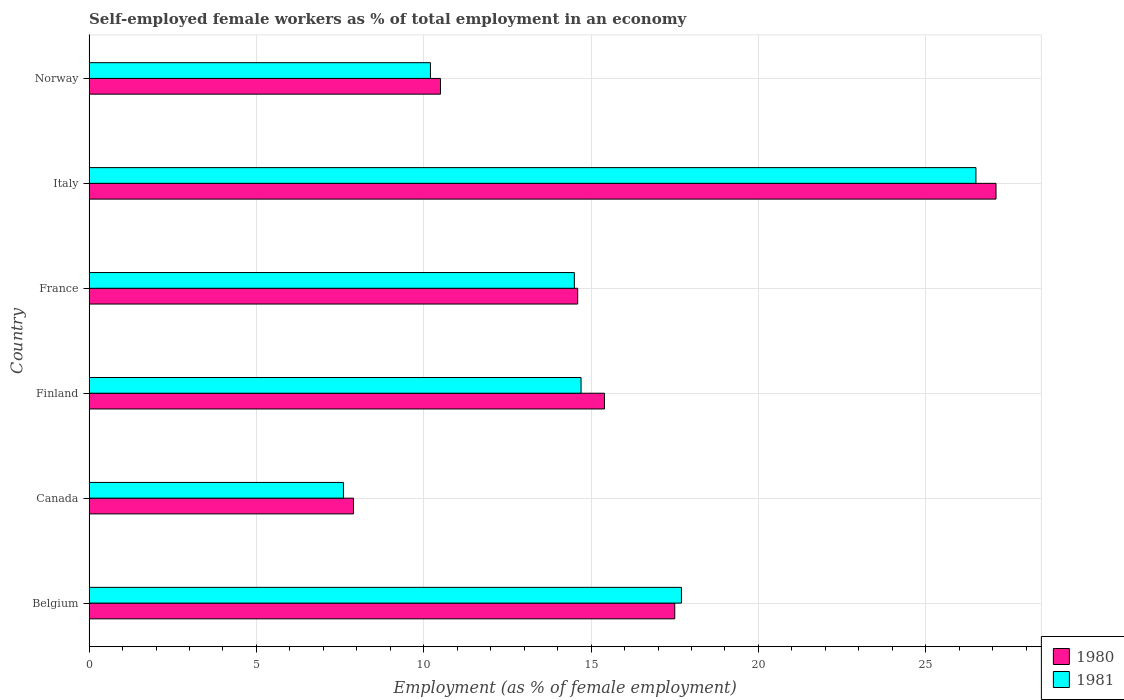How many different coloured bars are there?
Make the answer very short. 2. How many groups of bars are there?
Ensure brevity in your answer.  6. Are the number of bars per tick equal to the number of legend labels?
Your answer should be very brief. Yes. Are the number of bars on each tick of the Y-axis equal?
Provide a short and direct response. Yes. How many bars are there on the 2nd tick from the bottom?
Offer a very short reply. 2. In how many cases, is the number of bars for a given country not equal to the number of legend labels?
Provide a short and direct response. 0. What is the percentage of self-employed female workers in 1980 in France?
Offer a very short reply. 14.6. Across all countries, what is the maximum percentage of self-employed female workers in 1981?
Give a very brief answer. 26.5. Across all countries, what is the minimum percentage of self-employed female workers in 1980?
Keep it short and to the point. 7.9. What is the total percentage of self-employed female workers in 1981 in the graph?
Your response must be concise. 91.2. What is the difference between the percentage of self-employed female workers in 1981 in Belgium and that in France?
Provide a short and direct response. 3.2. What is the difference between the percentage of self-employed female workers in 1980 in Belgium and the percentage of self-employed female workers in 1981 in Canada?
Provide a succinct answer. 9.9. What is the average percentage of self-employed female workers in 1980 per country?
Your response must be concise. 15.5. What is the difference between the percentage of self-employed female workers in 1980 and percentage of self-employed female workers in 1981 in Italy?
Make the answer very short. 0.6. What is the ratio of the percentage of self-employed female workers in 1980 in Canada to that in France?
Give a very brief answer. 0.54. Is the percentage of self-employed female workers in 1980 in France less than that in Italy?
Offer a terse response. Yes. What is the difference between the highest and the second highest percentage of self-employed female workers in 1980?
Offer a very short reply. 9.6. What is the difference between the highest and the lowest percentage of self-employed female workers in 1981?
Your answer should be very brief. 18.9. In how many countries, is the percentage of self-employed female workers in 1980 greater than the average percentage of self-employed female workers in 1980 taken over all countries?
Give a very brief answer. 2. What does the 2nd bar from the top in Belgium represents?
Provide a short and direct response. 1980. How many bars are there?
Provide a short and direct response. 12. Are all the bars in the graph horizontal?
Give a very brief answer. Yes. How many countries are there in the graph?
Make the answer very short. 6. What is the difference between two consecutive major ticks on the X-axis?
Your response must be concise. 5. Are the values on the major ticks of X-axis written in scientific E-notation?
Your answer should be very brief. No. Where does the legend appear in the graph?
Ensure brevity in your answer.  Bottom right. How many legend labels are there?
Provide a short and direct response. 2. How are the legend labels stacked?
Offer a terse response. Vertical. What is the title of the graph?
Your answer should be very brief. Self-employed female workers as % of total employment in an economy. Does "2011" appear as one of the legend labels in the graph?
Provide a succinct answer. No. What is the label or title of the X-axis?
Your answer should be very brief. Employment (as % of female employment). What is the label or title of the Y-axis?
Your answer should be very brief. Country. What is the Employment (as % of female employment) in 1980 in Belgium?
Offer a terse response. 17.5. What is the Employment (as % of female employment) of 1981 in Belgium?
Provide a succinct answer. 17.7. What is the Employment (as % of female employment) in 1980 in Canada?
Your answer should be compact. 7.9. What is the Employment (as % of female employment) in 1981 in Canada?
Offer a very short reply. 7.6. What is the Employment (as % of female employment) of 1980 in Finland?
Offer a terse response. 15.4. What is the Employment (as % of female employment) of 1981 in Finland?
Your answer should be compact. 14.7. What is the Employment (as % of female employment) of 1980 in France?
Offer a very short reply. 14.6. What is the Employment (as % of female employment) in 1981 in France?
Make the answer very short. 14.5. What is the Employment (as % of female employment) in 1980 in Italy?
Offer a terse response. 27.1. What is the Employment (as % of female employment) in 1981 in Italy?
Make the answer very short. 26.5. What is the Employment (as % of female employment) of 1980 in Norway?
Give a very brief answer. 10.5. What is the Employment (as % of female employment) of 1981 in Norway?
Your answer should be compact. 10.2. Across all countries, what is the maximum Employment (as % of female employment) in 1980?
Make the answer very short. 27.1. Across all countries, what is the maximum Employment (as % of female employment) of 1981?
Offer a terse response. 26.5. Across all countries, what is the minimum Employment (as % of female employment) in 1980?
Provide a short and direct response. 7.9. Across all countries, what is the minimum Employment (as % of female employment) in 1981?
Offer a terse response. 7.6. What is the total Employment (as % of female employment) in 1980 in the graph?
Keep it short and to the point. 93. What is the total Employment (as % of female employment) of 1981 in the graph?
Ensure brevity in your answer.  91.2. What is the difference between the Employment (as % of female employment) in 1980 in Belgium and that in France?
Provide a short and direct response. 2.9. What is the difference between the Employment (as % of female employment) in 1981 in Belgium and that in France?
Give a very brief answer. 3.2. What is the difference between the Employment (as % of female employment) of 1980 in Belgium and that in Norway?
Make the answer very short. 7. What is the difference between the Employment (as % of female employment) in 1981 in Canada and that in Finland?
Your answer should be compact. -7.1. What is the difference between the Employment (as % of female employment) in 1981 in Canada and that in France?
Provide a short and direct response. -6.9. What is the difference between the Employment (as % of female employment) in 1980 in Canada and that in Italy?
Offer a terse response. -19.2. What is the difference between the Employment (as % of female employment) in 1981 in Canada and that in Italy?
Make the answer very short. -18.9. What is the difference between the Employment (as % of female employment) of 1980 in Canada and that in Norway?
Offer a very short reply. -2.6. What is the difference between the Employment (as % of female employment) in 1980 in Finland and that in France?
Provide a short and direct response. 0.8. What is the difference between the Employment (as % of female employment) in 1980 in Finland and that in Italy?
Your answer should be very brief. -11.7. What is the difference between the Employment (as % of female employment) in 1981 in Finland and that in Italy?
Your answer should be compact. -11.8. What is the difference between the Employment (as % of female employment) in 1980 in France and that in Italy?
Provide a short and direct response. -12.5. What is the difference between the Employment (as % of female employment) of 1981 in France and that in Italy?
Ensure brevity in your answer.  -12. What is the difference between the Employment (as % of female employment) of 1980 in Italy and that in Norway?
Make the answer very short. 16.6. What is the difference between the Employment (as % of female employment) of 1981 in Italy and that in Norway?
Keep it short and to the point. 16.3. What is the difference between the Employment (as % of female employment) in 1980 in Belgium and the Employment (as % of female employment) in 1981 in Finland?
Provide a succinct answer. 2.8. What is the difference between the Employment (as % of female employment) in 1980 in Belgium and the Employment (as % of female employment) in 1981 in Italy?
Provide a short and direct response. -9. What is the difference between the Employment (as % of female employment) of 1980 in Belgium and the Employment (as % of female employment) of 1981 in Norway?
Keep it short and to the point. 7.3. What is the difference between the Employment (as % of female employment) of 1980 in Canada and the Employment (as % of female employment) of 1981 in Finland?
Offer a terse response. -6.8. What is the difference between the Employment (as % of female employment) in 1980 in Canada and the Employment (as % of female employment) in 1981 in Italy?
Your answer should be very brief. -18.6. What is the difference between the Employment (as % of female employment) in 1980 in Canada and the Employment (as % of female employment) in 1981 in Norway?
Your answer should be compact. -2.3. What is the difference between the Employment (as % of female employment) in 1980 in Finland and the Employment (as % of female employment) in 1981 in Norway?
Ensure brevity in your answer.  5.2. What is the difference between the Employment (as % of female employment) in 1980 in Italy and the Employment (as % of female employment) in 1981 in Norway?
Make the answer very short. 16.9. What is the average Employment (as % of female employment) in 1981 per country?
Provide a short and direct response. 15.2. What is the difference between the Employment (as % of female employment) in 1980 and Employment (as % of female employment) in 1981 in Italy?
Offer a very short reply. 0.6. What is the ratio of the Employment (as % of female employment) of 1980 in Belgium to that in Canada?
Make the answer very short. 2.22. What is the ratio of the Employment (as % of female employment) of 1981 in Belgium to that in Canada?
Provide a succinct answer. 2.33. What is the ratio of the Employment (as % of female employment) of 1980 in Belgium to that in Finland?
Your answer should be compact. 1.14. What is the ratio of the Employment (as % of female employment) in 1981 in Belgium to that in Finland?
Your answer should be compact. 1.2. What is the ratio of the Employment (as % of female employment) in 1980 in Belgium to that in France?
Offer a terse response. 1.2. What is the ratio of the Employment (as % of female employment) of 1981 in Belgium to that in France?
Keep it short and to the point. 1.22. What is the ratio of the Employment (as % of female employment) of 1980 in Belgium to that in Italy?
Your answer should be very brief. 0.65. What is the ratio of the Employment (as % of female employment) of 1981 in Belgium to that in Italy?
Your answer should be very brief. 0.67. What is the ratio of the Employment (as % of female employment) of 1980 in Belgium to that in Norway?
Give a very brief answer. 1.67. What is the ratio of the Employment (as % of female employment) of 1981 in Belgium to that in Norway?
Keep it short and to the point. 1.74. What is the ratio of the Employment (as % of female employment) of 1980 in Canada to that in Finland?
Make the answer very short. 0.51. What is the ratio of the Employment (as % of female employment) of 1981 in Canada to that in Finland?
Make the answer very short. 0.52. What is the ratio of the Employment (as % of female employment) in 1980 in Canada to that in France?
Ensure brevity in your answer.  0.54. What is the ratio of the Employment (as % of female employment) in 1981 in Canada to that in France?
Provide a succinct answer. 0.52. What is the ratio of the Employment (as % of female employment) in 1980 in Canada to that in Italy?
Keep it short and to the point. 0.29. What is the ratio of the Employment (as % of female employment) in 1981 in Canada to that in Italy?
Your answer should be compact. 0.29. What is the ratio of the Employment (as % of female employment) of 1980 in Canada to that in Norway?
Give a very brief answer. 0.75. What is the ratio of the Employment (as % of female employment) in 1981 in Canada to that in Norway?
Give a very brief answer. 0.75. What is the ratio of the Employment (as % of female employment) in 1980 in Finland to that in France?
Your answer should be compact. 1.05. What is the ratio of the Employment (as % of female employment) of 1981 in Finland to that in France?
Ensure brevity in your answer.  1.01. What is the ratio of the Employment (as % of female employment) of 1980 in Finland to that in Italy?
Give a very brief answer. 0.57. What is the ratio of the Employment (as % of female employment) in 1981 in Finland to that in Italy?
Your answer should be compact. 0.55. What is the ratio of the Employment (as % of female employment) in 1980 in Finland to that in Norway?
Provide a short and direct response. 1.47. What is the ratio of the Employment (as % of female employment) in 1981 in Finland to that in Norway?
Your response must be concise. 1.44. What is the ratio of the Employment (as % of female employment) in 1980 in France to that in Italy?
Offer a terse response. 0.54. What is the ratio of the Employment (as % of female employment) in 1981 in France to that in Italy?
Give a very brief answer. 0.55. What is the ratio of the Employment (as % of female employment) of 1980 in France to that in Norway?
Make the answer very short. 1.39. What is the ratio of the Employment (as % of female employment) of 1981 in France to that in Norway?
Provide a short and direct response. 1.42. What is the ratio of the Employment (as % of female employment) of 1980 in Italy to that in Norway?
Offer a terse response. 2.58. What is the ratio of the Employment (as % of female employment) in 1981 in Italy to that in Norway?
Your response must be concise. 2.6. What is the difference between the highest and the second highest Employment (as % of female employment) of 1980?
Keep it short and to the point. 9.6. What is the difference between the highest and the second highest Employment (as % of female employment) of 1981?
Your response must be concise. 8.8. 